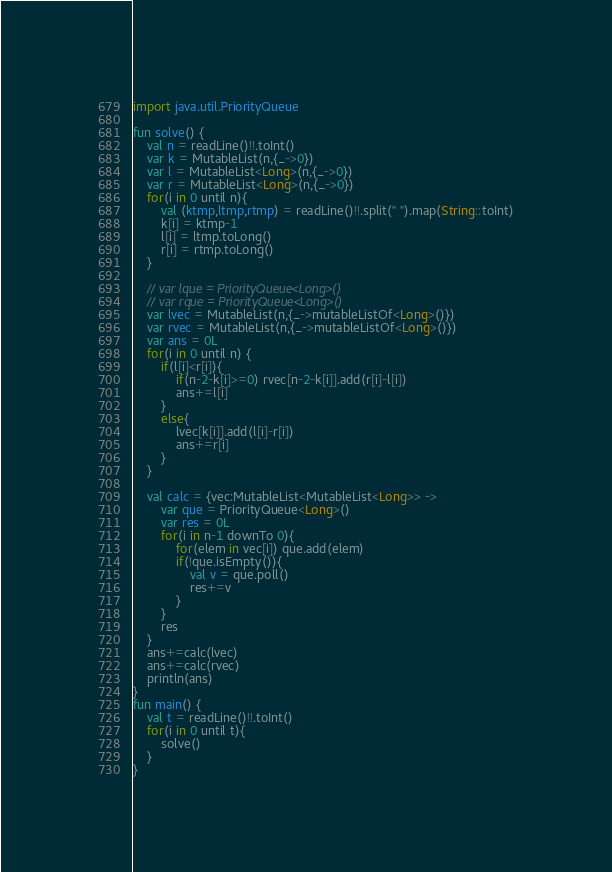<code> <loc_0><loc_0><loc_500><loc_500><_Kotlin_>import java.util.PriorityQueue

fun solve() {
    val n = readLine()!!.toInt()
    var k = MutableList(n,{_->0})    
    var l = MutableList<Long>(n,{_->0})    
    var r = MutableList<Long>(n,{_->0})    
    for(i in 0 until n){
        val (ktmp,ltmp,rtmp) = readLine()!!.split(" ").map(String::toInt)
        k[i] = ktmp-1
        l[i] = ltmp.toLong()
        r[i] = rtmp.toLong()
    }

    // var lque = PriorityQueue<Long>()
    // var rque = PriorityQueue<Long>()
    var lvec = MutableList(n,{_->mutableListOf<Long>()})
    var rvec = MutableList(n,{_->mutableListOf<Long>()})
    var ans = 0L
    for(i in 0 until n) {
        if(l[i]<r[i]){
            if(n-2-k[i]>=0) rvec[n-2-k[i]].add(r[i]-l[i])
            ans+=l[i]
        }
        else{
            lvec[k[i]].add(l[i]-r[i])
            ans+=r[i]
        }
    }

    val calc = {vec:MutableList<MutableList<Long>> ->
        var que = PriorityQueue<Long>()
        var res = 0L
        for(i in n-1 downTo 0){
            for(elem in vec[i]) que.add(elem)
            if(!que.isEmpty()){
                val v = que.poll()
                res+=v
            }   
        }
        res
    }
    ans+=calc(lvec)
    ans+=calc(rvec)
    println(ans)
}
fun main() {
    val t = readLine()!!.toInt()
    for(i in 0 until t){
        solve()
    }
}
</code> 